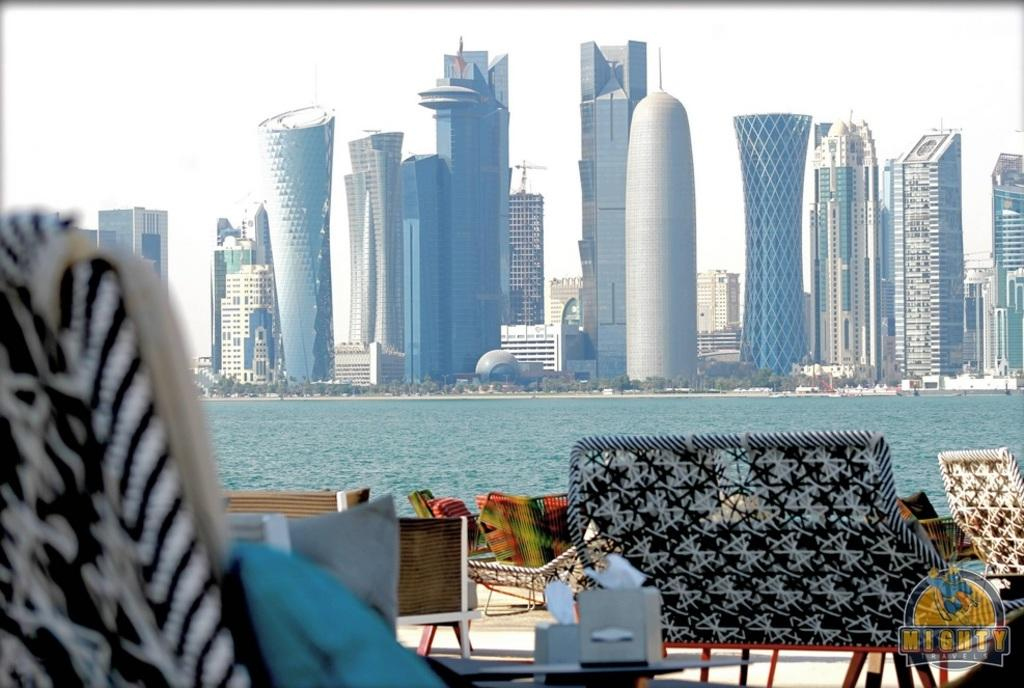What type of objects can be seen in the image? There are furniture items in the image. What is the primary element visible in the image? There is a water surface visible in the image. What can be seen in the background of the image? There are buildings and the sky visible in the background of the image. What type of drug is being used by the furniture in the image? There is no drug present in the image, as it features furniture items and a water surface with buildings and the sky in the background. 